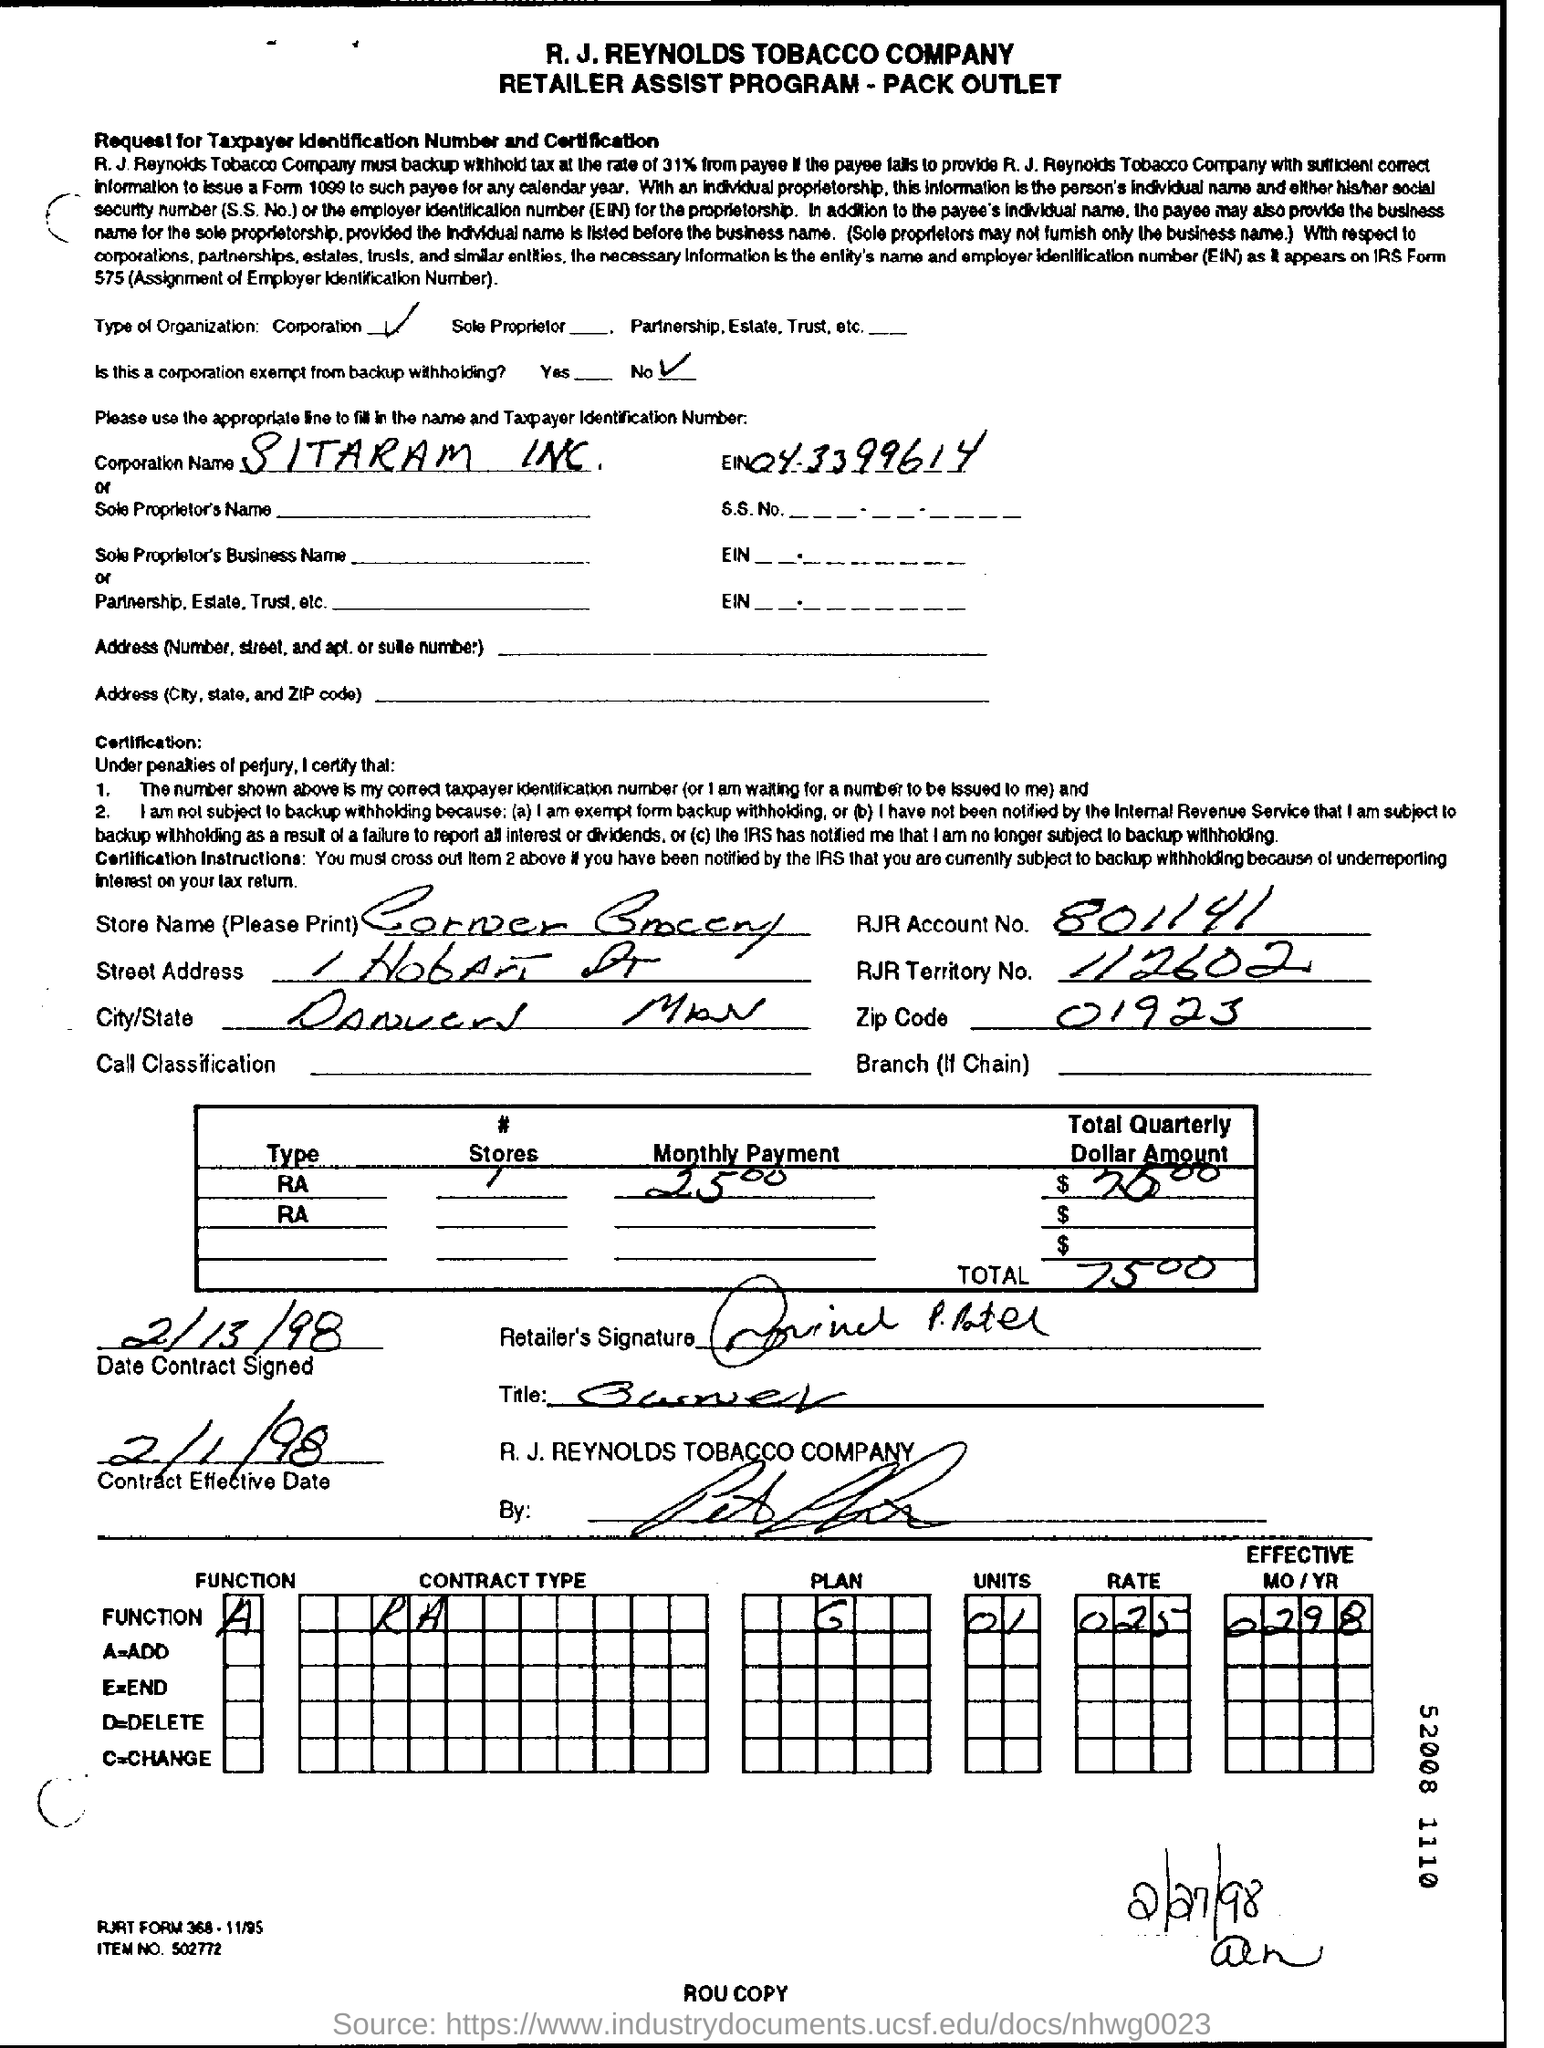Mention a couple of crucial points in this snapshot. SITARAM INC is the corporation name. The total quarterly dollar amount is $7,500. The EIN, or Employer Identification Number, for Sitaram inc. is 04.3399614. The store's name is Corner Grocery. This is not a corporation that is exempt from backup withholding. 